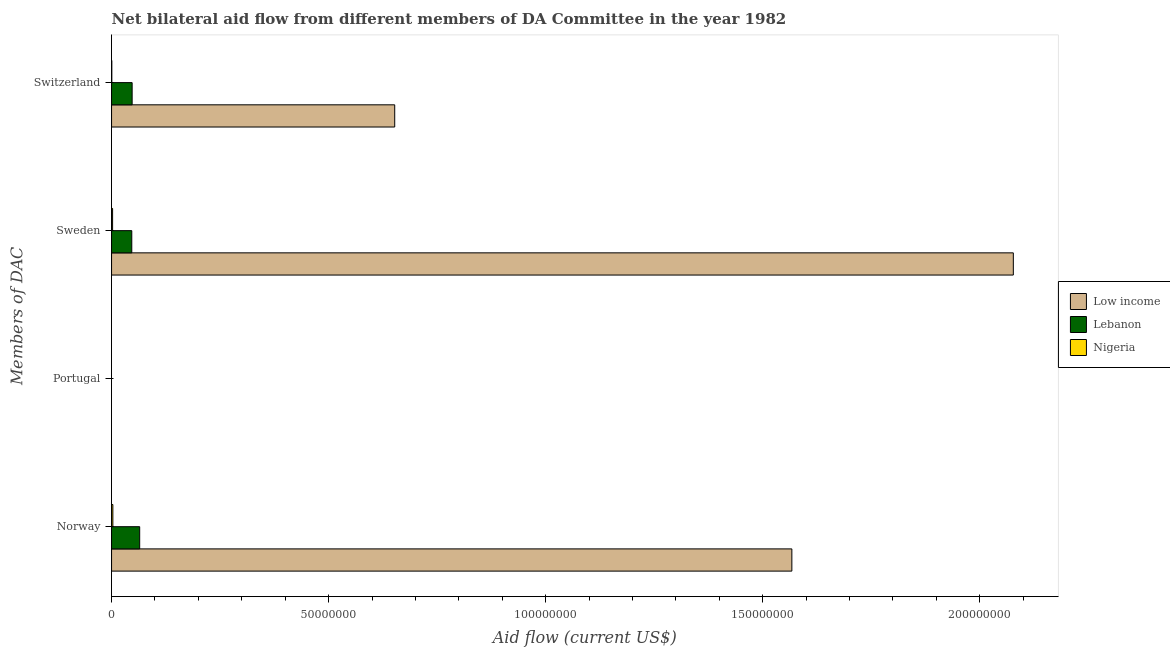How many bars are there on the 2nd tick from the bottom?
Give a very brief answer. 0. What is the label of the 2nd group of bars from the top?
Give a very brief answer. Sweden. What is the amount of aid given by norway in Nigeria?
Your answer should be very brief. 3.00e+05. Across all countries, what is the maximum amount of aid given by sweden?
Keep it short and to the point. 2.08e+08. Across all countries, what is the minimum amount of aid given by switzerland?
Your answer should be very brief. 6.00e+04. In which country was the amount of aid given by norway maximum?
Give a very brief answer. Low income. What is the total amount of aid given by sweden in the graph?
Your response must be concise. 2.13e+08. What is the difference between the amount of aid given by sweden in Nigeria and that in Low income?
Offer a very short reply. -2.08e+08. What is the difference between the amount of aid given by portugal in Low income and the amount of aid given by sweden in Lebanon?
Keep it short and to the point. -4.66e+06. What is the average amount of aid given by portugal per country?
Ensure brevity in your answer.  0. What is the ratio of the amount of aid given by norway in Nigeria to that in Low income?
Keep it short and to the point. 0. Is the amount of aid given by sweden in Lebanon less than that in Nigeria?
Give a very brief answer. No. Is the difference between the amount of aid given by norway in Lebanon and Nigeria greater than the difference between the amount of aid given by sweden in Lebanon and Nigeria?
Make the answer very short. Yes. What is the difference between the highest and the second highest amount of aid given by sweden?
Offer a very short reply. 2.03e+08. What is the difference between the highest and the lowest amount of aid given by norway?
Your response must be concise. 1.56e+08. Is the sum of the amount of aid given by norway in Nigeria and Low income greater than the maximum amount of aid given by portugal across all countries?
Give a very brief answer. Yes. Is it the case that in every country, the sum of the amount of aid given by switzerland and amount of aid given by sweden is greater than the sum of amount of aid given by portugal and amount of aid given by norway?
Offer a very short reply. No. Is it the case that in every country, the sum of the amount of aid given by norway and amount of aid given by portugal is greater than the amount of aid given by sweden?
Give a very brief answer. No. How many bars are there?
Offer a very short reply. 12. Are all the bars in the graph horizontal?
Your response must be concise. Yes. How many countries are there in the graph?
Ensure brevity in your answer.  3. What is the difference between two consecutive major ticks on the X-axis?
Your answer should be compact. 5.00e+07. Are the values on the major ticks of X-axis written in scientific E-notation?
Your answer should be compact. No. Does the graph contain any zero values?
Make the answer very short. Yes. How many legend labels are there?
Offer a very short reply. 3. What is the title of the graph?
Keep it short and to the point. Net bilateral aid flow from different members of DA Committee in the year 1982. Does "Kyrgyz Republic" appear as one of the legend labels in the graph?
Your answer should be compact. No. What is the label or title of the Y-axis?
Offer a very short reply. Members of DAC. What is the Aid flow (current US$) of Low income in Norway?
Offer a very short reply. 1.57e+08. What is the Aid flow (current US$) in Lebanon in Norway?
Make the answer very short. 6.48e+06. What is the Aid flow (current US$) of Low income in Portugal?
Your answer should be very brief. Nan. What is the Aid flow (current US$) of Lebanon in Portugal?
Ensure brevity in your answer.  Nan. What is the Aid flow (current US$) of Nigeria in Portugal?
Keep it short and to the point. Nan. What is the Aid flow (current US$) of Low income in Sweden?
Offer a terse response. 2.08e+08. What is the Aid flow (current US$) of Lebanon in Sweden?
Provide a short and direct response. 4.66e+06. What is the Aid flow (current US$) of Nigeria in Sweden?
Keep it short and to the point. 2.40e+05. What is the Aid flow (current US$) in Low income in Switzerland?
Your answer should be compact. 6.52e+07. What is the Aid flow (current US$) of Lebanon in Switzerland?
Ensure brevity in your answer.  4.74e+06. Across all Members of DAC, what is the maximum Aid flow (current US$) of Low income?
Offer a very short reply. 2.08e+08. Across all Members of DAC, what is the maximum Aid flow (current US$) of Lebanon?
Ensure brevity in your answer.  6.48e+06. Across all Members of DAC, what is the maximum Aid flow (current US$) of Nigeria?
Offer a very short reply. 3.00e+05. Across all Members of DAC, what is the minimum Aid flow (current US$) of Low income?
Give a very brief answer. 6.52e+07. Across all Members of DAC, what is the minimum Aid flow (current US$) in Lebanon?
Offer a very short reply. 4.66e+06. Across all Members of DAC, what is the minimum Aid flow (current US$) in Nigeria?
Keep it short and to the point. 6.00e+04. What is the total Aid flow (current US$) of Low income in the graph?
Your answer should be compact. 4.30e+08. What is the total Aid flow (current US$) of Lebanon in the graph?
Offer a very short reply. 1.59e+07. What is the total Aid flow (current US$) of Nigeria in the graph?
Provide a succinct answer. 6.00e+05. What is the difference between the Aid flow (current US$) of Low income in Norway and that in Portugal?
Your answer should be very brief. Nan. What is the difference between the Aid flow (current US$) in Lebanon in Norway and that in Portugal?
Keep it short and to the point. Nan. What is the difference between the Aid flow (current US$) of Nigeria in Norway and that in Portugal?
Provide a succinct answer. Nan. What is the difference between the Aid flow (current US$) in Low income in Norway and that in Sweden?
Offer a terse response. -5.10e+07. What is the difference between the Aid flow (current US$) in Lebanon in Norway and that in Sweden?
Your answer should be compact. 1.82e+06. What is the difference between the Aid flow (current US$) in Nigeria in Norway and that in Sweden?
Give a very brief answer. 6.00e+04. What is the difference between the Aid flow (current US$) in Low income in Norway and that in Switzerland?
Provide a short and direct response. 9.15e+07. What is the difference between the Aid flow (current US$) of Lebanon in Norway and that in Switzerland?
Keep it short and to the point. 1.74e+06. What is the difference between the Aid flow (current US$) in Nigeria in Norway and that in Switzerland?
Ensure brevity in your answer.  2.40e+05. What is the difference between the Aid flow (current US$) in Low income in Portugal and that in Sweden?
Keep it short and to the point. Nan. What is the difference between the Aid flow (current US$) of Lebanon in Portugal and that in Sweden?
Ensure brevity in your answer.  Nan. What is the difference between the Aid flow (current US$) in Nigeria in Portugal and that in Sweden?
Your response must be concise. Nan. What is the difference between the Aid flow (current US$) in Low income in Portugal and that in Switzerland?
Make the answer very short. Nan. What is the difference between the Aid flow (current US$) of Lebanon in Portugal and that in Switzerland?
Give a very brief answer. Nan. What is the difference between the Aid flow (current US$) of Nigeria in Portugal and that in Switzerland?
Give a very brief answer. Nan. What is the difference between the Aid flow (current US$) of Low income in Sweden and that in Switzerland?
Give a very brief answer. 1.43e+08. What is the difference between the Aid flow (current US$) in Lebanon in Sweden and that in Switzerland?
Provide a succinct answer. -8.00e+04. What is the difference between the Aid flow (current US$) of Nigeria in Sweden and that in Switzerland?
Provide a short and direct response. 1.80e+05. What is the difference between the Aid flow (current US$) of Low income in Norway and the Aid flow (current US$) of Lebanon in Portugal?
Ensure brevity in your answer.  Nan. What is the difference between the Aid flow (current US$) in Low income in Norway and the Aid flow (current US$) in Nigeria in Portugal?
Offer a very short reply. Nan. What is the difference between the Aid flow (current US$) in Lebanon in Norway and the Aid flow (current US$) in Nigeria in Portugal?
Provide a succinct answer. Nan. What is the difference between the Aid flow (current US$) of Low income in Norway and the Aid flow (current US$) of Lebanon in Sweden?
Ensure brevity in your answer.  1.52e+08. What is the difference between the Aid flow (current US$) of Low income in Norway and the Aid flow (current US$) of Nigeria in Sweden?
Your response must be concise. 1.56e+08. What is the difference between the Aid flow (current US$) in Lebanon in Norway and the Aid flow (current US$) in Nigeria in Sweden?
Provide a short and direct response. 6.24e+06. What is the difference between the Aid flow (current US$) of Low income in Norway and the Aid flow (current US$) of Lebanon in Switzerland?
Offer a very short reply. 1.52e+08. What is the difference between the Aid flow (current US$) of Low income in Norway and the Aid flow (current US$) of Nigeria in Switzerland?
Offer a terse response. 1.57e+08. What is the difference between the Aid flow (current US$) in Lebanon in Norway and the Aid flow (current US$) in Nigeria in Switzerland?
Keep it short and to the point. 6.42e+06. What is the difference between the Aid flow (current US$) in Low income in Portugal and the Aid flow (current US$) in Lebanon in Sweden?
Ensure brevity in your answer.  Nan. What is the difference between the Aid flow (current US$) in Low income in Portugal and the Aid flow (current US$) in Nigeria in Sweden?
Keep it short and to the point. Nan. What is the difference between the Aid flow (current US$) in Lebanon in Portugal and the Aid flow (current US$) in Nigeria in Sweden?
Offer a terse response. Nan. What is the difference between the Aid flow (current US$) of Low income in Portugal and the Aid flow (current US$) of Lebanon in Switzerland?
Make the answer very short. Nan. What is the difference between the Aid flow (current US$) of Low income in Portugal and the Aid flow (current US$) of Nigeria in Switzerland?
Provide a succinct answer. Nan. What is the difference between the Aid flow (current US$) of Lebanon in Portugal and the Aid flow (current US$) of Nigeria in Switzerland?
Ensure brevity in your answer.  Nan. What is the difference between the Aid flow (current US$) of Low income in Sweden and the Aid flow (current US$) of Lebanon in Switzerland?
Your answer should be compact. 2.03e+08. What is the difference between the Aid flow (current US$) of Low income in Sweden and the Aid flow (current US$) of Nigeria in Switzerland?
Your answer should be very brief. 2.08e+08. What is the difference between the Aid flow (current US$) of Lebanon in Sweden and the Aid flow (current US$) of Nigeria in Switzerland?
Offer a very short reply. 4.60e+06. What is the average Aid flow (current US$) in Low income per Members of DAC?
Provide a succinct answer. 1.07e+08. What is the average Aid flow (current US$) of Lebanon per Members of DAC?
Your answer should be very brief. 3.97e+06. What is the average Aid flow (current US$) of Nigeria per Members of DAC?
Offer a very short reply. 1.50e+05. What is the difference between the Aid flow (current US$) in Low income and Aid flow (current US$) in Lebanon in Norway?
Offer a terse response. 1.50e+08. What is the difference between the Aid flow (current US$) of Low income and Aid flow (current US$) of Nigeria in Norway?
Offer a very short reply. 1.56e+08. What is the difference between the Aid flow (current US$) of Lebanon and Aid flow (current US$) of Nigeria in Norway?
Offer a terse response. 6.18e+06. What is the difference between the Aid flow (current US$) of Low income and Aid flow (current US$) of Lebanon in Portugal?
Provide a succinct answer. Nan. What is the difference between the Aid flow (current US$) in Low income and Aid flow (current US$) in Nigeria in Portugal?
Provide a succinct answer. Nan. What is the difference between the Aid flow (current US$) in Lebanon and Aid flow (current US$) in Nigeria in Portugal?
Keep it short and to the point. Nan. What is the difference between the Aid flow (current US$) in Low income and Aid flow (current US$) in Lebanon in Sweden?
Keep it short and to the point. 2.03e+08. What is the difference between the Aid flow (current US$) of Low income and Aid flow (current US$) of Nigeria in Sweden?
Offer a terse response. 2.08e+08. What is the difference between the Aid flow (current US$) in Lebanon and Aid flow (current US$) in Nigeria in Sweden?
Provide a succinct answer. 4.42e+06. What is the difference between the Aid flow (current US$) in Low income and Aid flow (current US$) in Lebanon in Switzerland?
Offer a terse response. 6.05e+07. What is the difference between the Aid flow (current US$) of Low income and Aid flow (current US$) of Nigeria in Switzerland?
Your response must be concise. 6.52e+07. What is the difference between the Aid flow (current US$) of Lebanon and Aid flow (current US$) of Nigeria in Switzerland?
Provide a short and direct response. 4.68e+06. What is the ratio of the Aid flow (current US$) in Low income in Norway to that in Portugal?
Offer a terse response. Nan. What is the ratio of the Aid flow (current US$) in Lebanon in Norway to that in Portugal?
Your answer should be compact. Nan. What is the ratio of the Aid flow (current US$) of Nigeria in Norway to that in Portugal?
Ensure brevity in your answer.  Nan. What is the ratio of the Aid flow (current US$) in Low income in Norway to that in Sweden?
Your response must be concise. 0.75. What is the ratio of the Aid flow (current US$) in Lebanon in Norway to that in Sweden?
Provide a short and direct response. 1.39. What is the ratio of the Aid flow (current US$) in Low income in Norway to that in Switzerland?
Offer a terse response. 2.4. What is the ratio of the Aid flow (current US$) in Lebanon in Norway to that in Switzerland?
Provide a short and direct response. 1.37. What is the ratio of the Aid flow (current US$) in Nigeria in Norway to that in Switzerland?
Your answer should be compact. 5. What is the ratio of the Aid flow (current US$) in Low income in Portugal to that in Sweden?
Give a very brief answer. Nan. What is the ratio of the Aid flow (current US$) in Lebanon in Portugal to that in Sweden?
Provide a short and direct response. Nan. What is the ratio of the Aid flow (current US$) in Nigeria in Portugal to that in Sweden?
Ensure brevity in your answer.  Nan. What is the ratio of the Aid flow (current US$) of Low income in Portugal to that in Switzerland?
Give a very brief answer. Nan. What is the ratio of the Aid flow (current US$) of Lebanon in Portugal to that in Switzerland?
Provide a succinct answer. Nan. What is the ratio of the Aid flow (current US$) in Nigeria in Portugal to that in Switzerland?
Give a very brief answer. Nan. What is the ratio of the Aid flow (current US$) of Low income in Sweden to that in Switzerland?
Provide a short and direct response. 3.18. What is the ratio of the Aid flow (current US$) in Lebanon in Sweden to that in Switzerland?
Ensure brevity in your answer.  0.98. What is the difference between the highest and the second highest Aid flow (current US$) in Low income?
Give a very brief answer. 5.10e+07. What is the difference between the highest and the second highest Aid flow (current US$) in Lebanon?
Ensure brevity in your answer.  1.74e+06. What is the difference between the highest and the lowest Aid flow (current US$) in Low income?
Your answer should be compact. 1.43e+08. What is the difference between the highest and the lowest Aid flow (current US$) in Lebanon?
Give a very brief answer. 1.82e+06. 